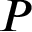Convert formula to latex. <formula><loc_0><loc_0><loc_500><loc_500>P</formula> 